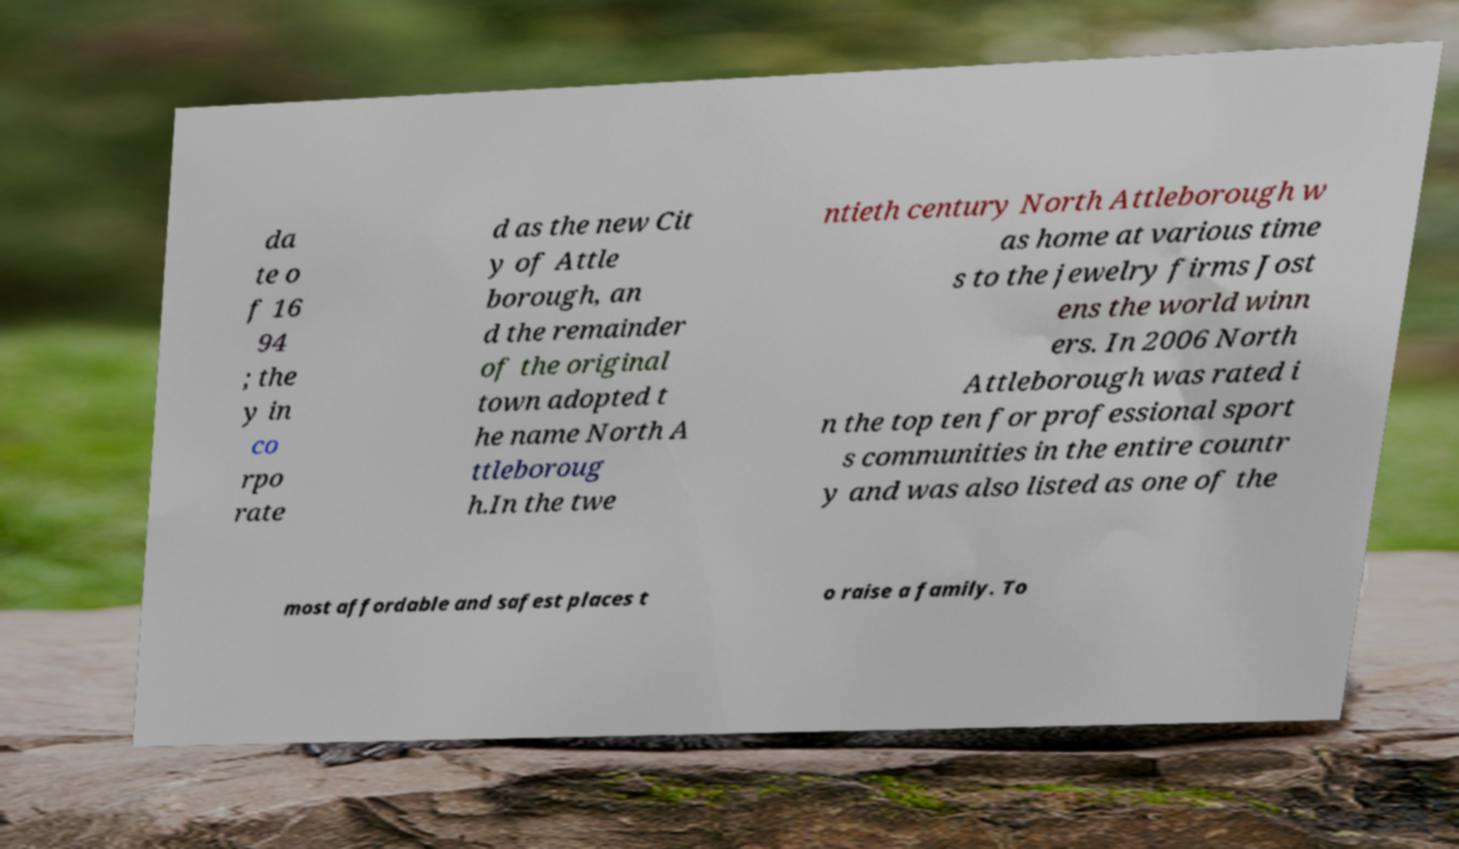Can you accurately transcribe the text from the provided image for me? da te o f 16 94 ; the y in co rpo rate d as the new Cit y of Attle borough, an d the remainder of the original town adopted t he name North A ttleboroug h.In the twe ntieth century North Attleborough w as home at various time s to the jewelry firms Jost ens the world winn ers. In 2006 North Attleborough was rated i n the top ten for professional sport s communities in the entire countr y and was also listed as one of the most affordable and safest places t o raise a family. To 